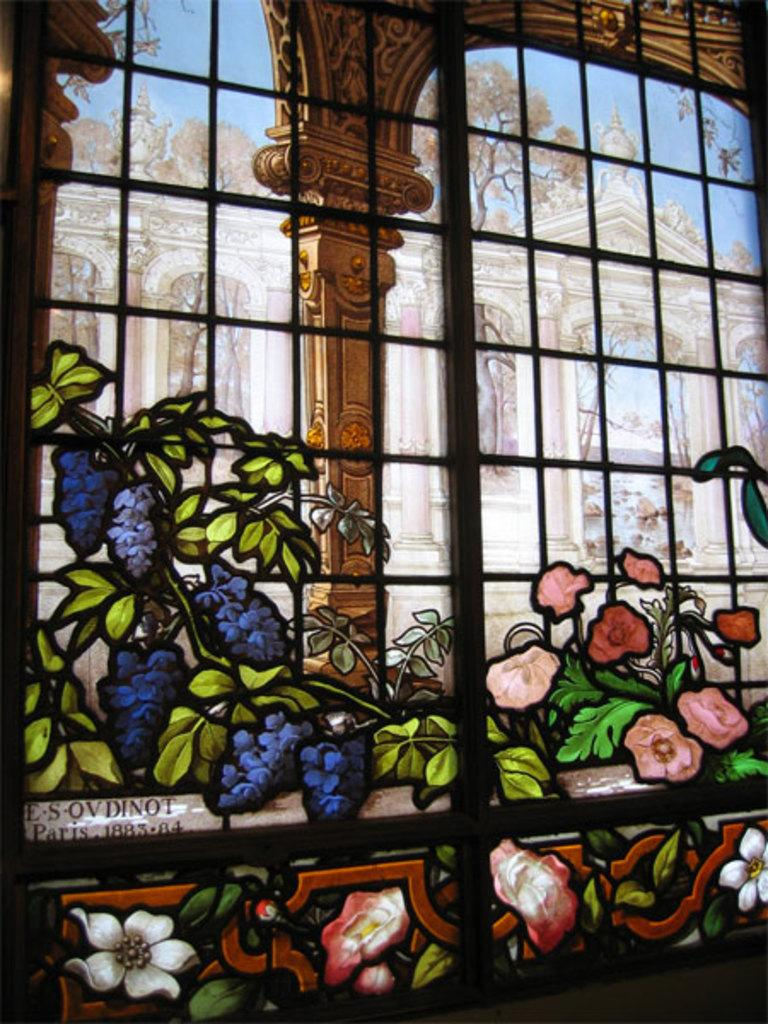What is depicted in the painting in the image? The painting contains flowers and leaves. What architectural feature can be seen in the image? There is a grille in the image. What can be seen in the background of the image? There is a building, trees, and the sky visible in the background of the image. How many spiders are crawling on the desk in the image? There is no desk or spiders present in the image. 